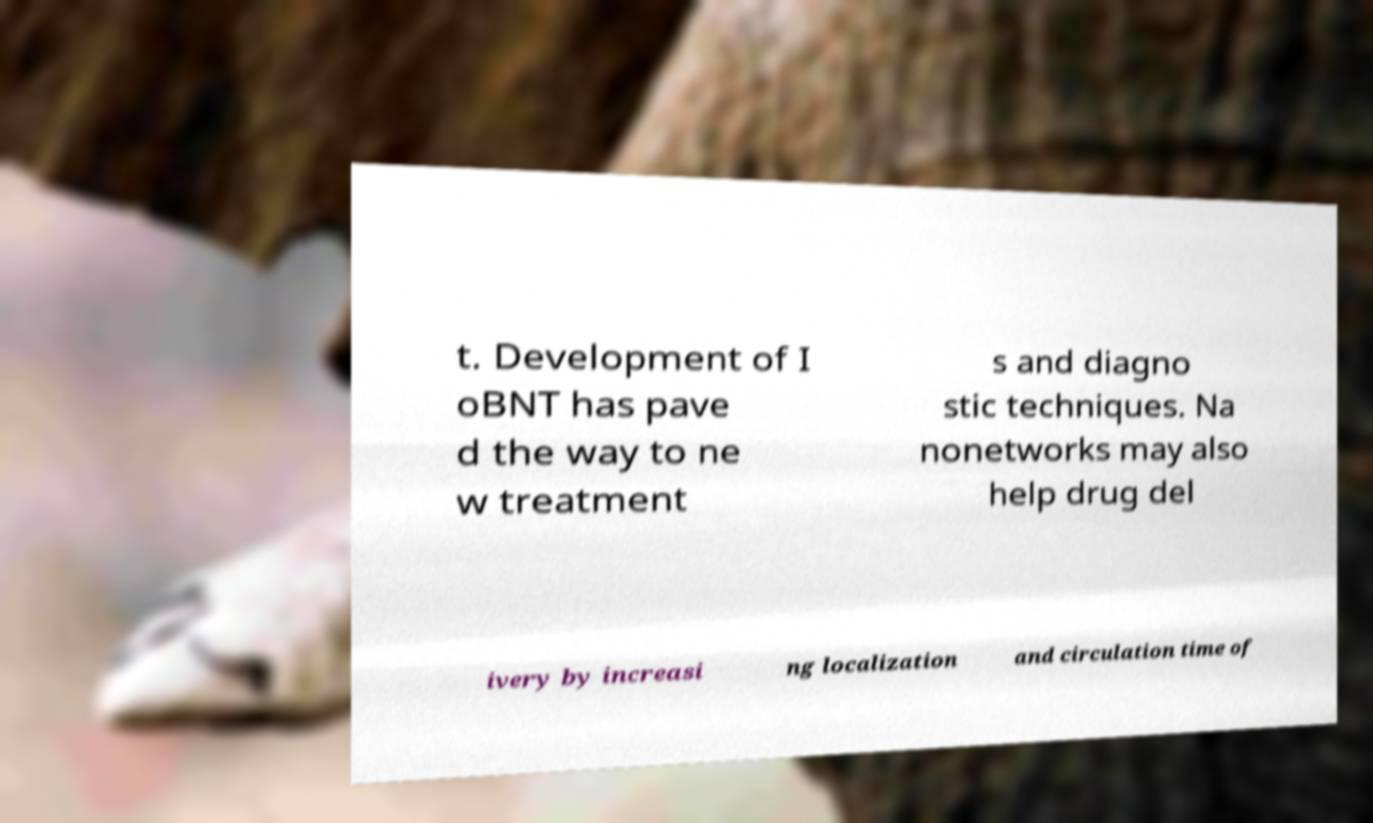For documentation purposes, I need the text within this image transcribed. Could you provide that? t. Development of I oBNT has pave d the way to ne w treatment s and diagno stic techniques. Na nonetworks may also help drug del ivery by increasi ng localization and circulation time of 